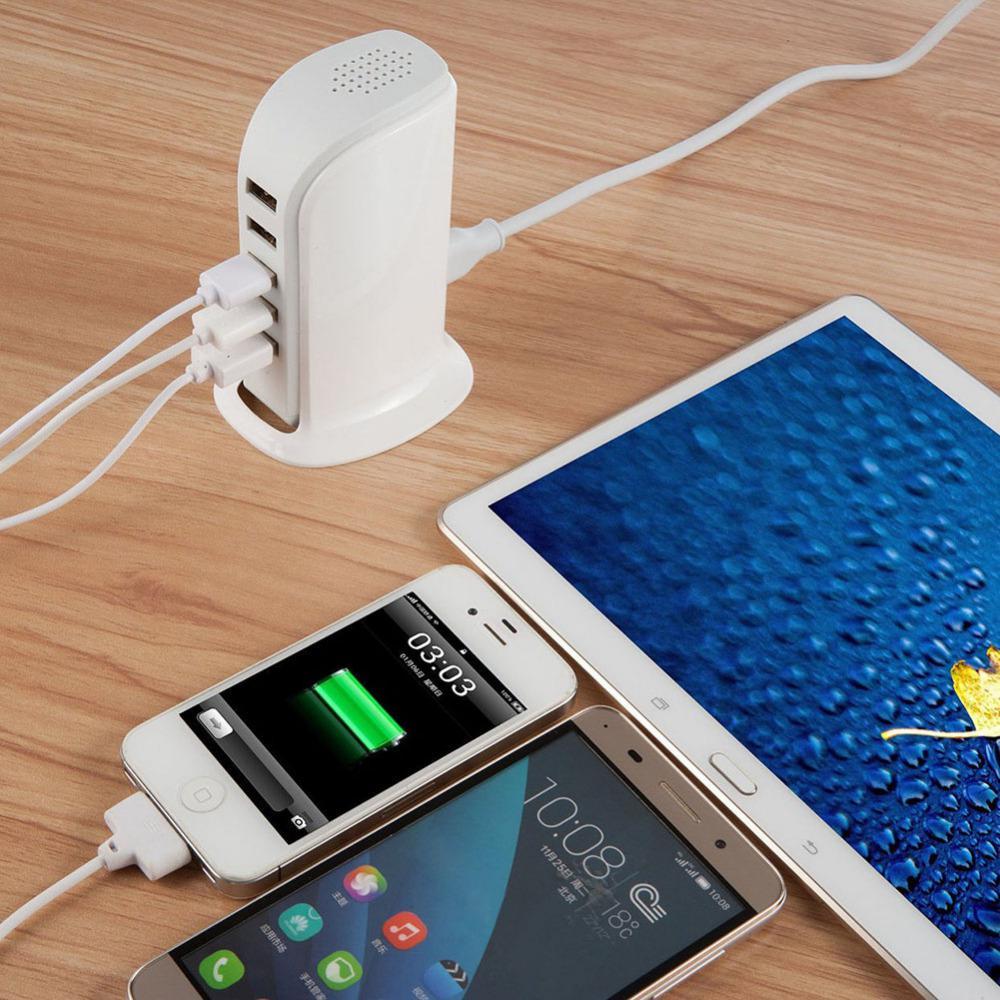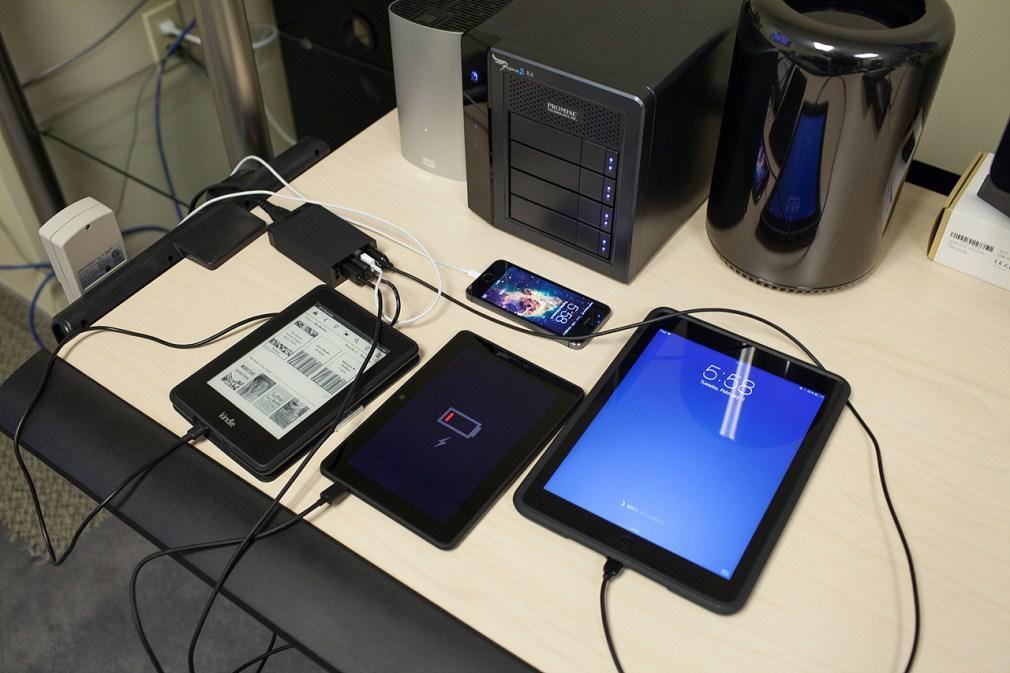The first image is the image on the left, the second image is the image on the right. Assess this claim about the two images: "The devices in the left image are plugged into a black colored charging station.". Correct or not? Answer yes or no. No. The first image is the image on the left, the second image is the image on the right. Analyze the images presented: Is the assertion "An image shows an upright charging station with one white cord in the back and several cords all of one color in the front, with multiple screened devices lying flat nearby it on a wood-grain surface." valid? Answer yes or no. Yes. 